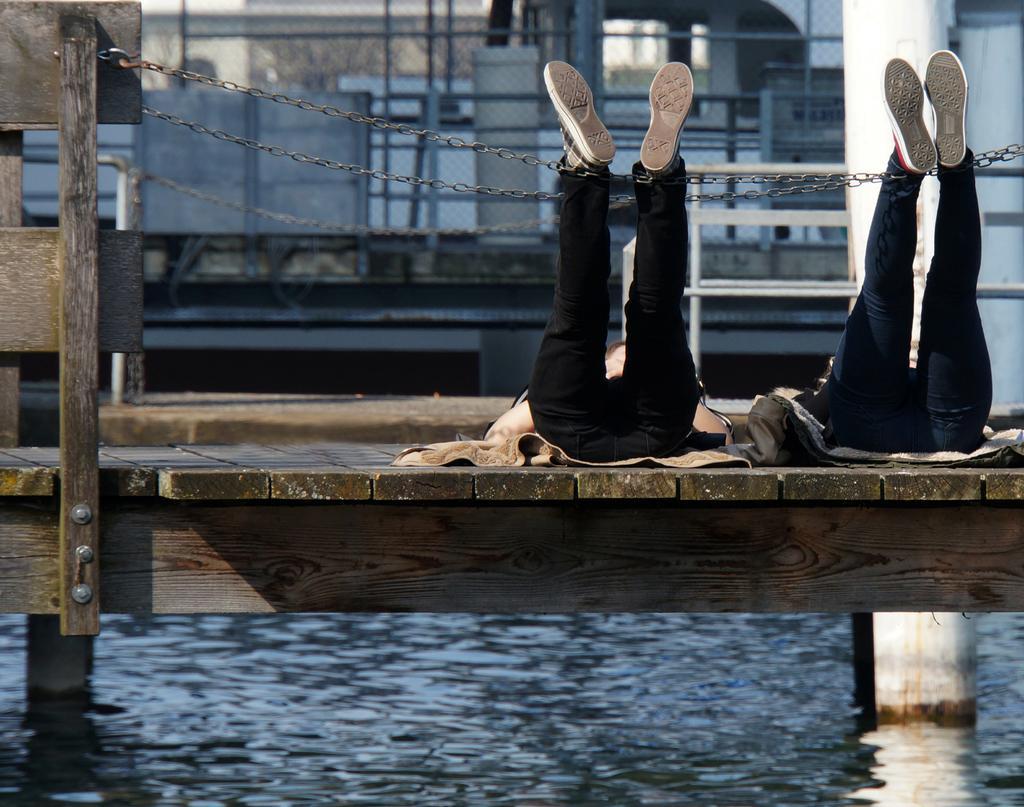Please provide a concise description of this image. In this picture I can see water. I can see wooden piers and there are two persons lying on the wooden pier. I can see fence, chains and some other objects. 